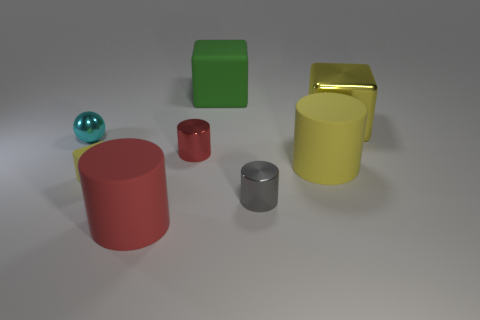Add 1 big red rubber cylinders. How many objects exist? 9 Subtract all small red cylinders. How many cylinders are left? 3 Subtract all gray cylinders. How many cylinders are left? 3 Subtract all spheres. How many objects are left? 7 Subtract 1 cylinders. How many cylinders are left? 3 Subtract all blue cylinders. Subtract all gray cubes. How many cylinders are left? 4 Subtract all blue cylinders. How many yellow blocks are left? 2 Subtract all large gray matte cubes. Subtract all big yellow blocks. How many objects are left? 7 Add 4 big matte cylinders. How many big matte cylinders are left? 6 Add 6 small brown matte balls. How many small brown matte balls exist? 6 